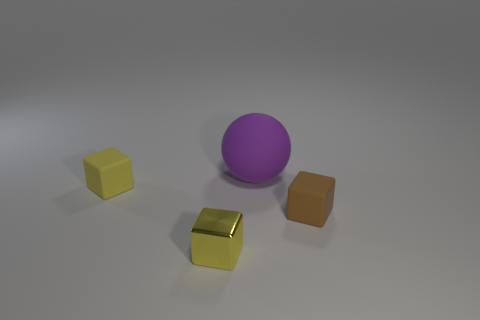Is there any other thing that is the same size as the purple sphere?
Make the answer very short. No. How many cubes are tiny matte objects or metal objects?
Your response must be concise. 3. What number of cyan cylinders are there?
Ensure brevity in your answer.  0. There is a shiny thing; does it have the same shape as the object behind the yellow rubber cube?
Your response must be concise. No. There is a ball that is behind the small yellow metallic object; what is its size?
Provide a short and direct response. Large. What material is the brown thing?
Your answer should be very brief. Rubber. There is a matte object that is to the left of the big matte object; is it the same shape as the purple rubber object?
Offer a terse response. No. Are there any matte objects that have the same size as the purple sphere?
Provide a succinct answer. No. There is a yellow thing in front of the small yellow object that is left of the yellow metal object; are there any large matte balls that are on the right side of it?
Make the answer very short. Yes. Does the tiny shiny thing have the same color as the rubber block that is on the left side of the brown thing?
Ensure brevity in your answer.  Yes. 